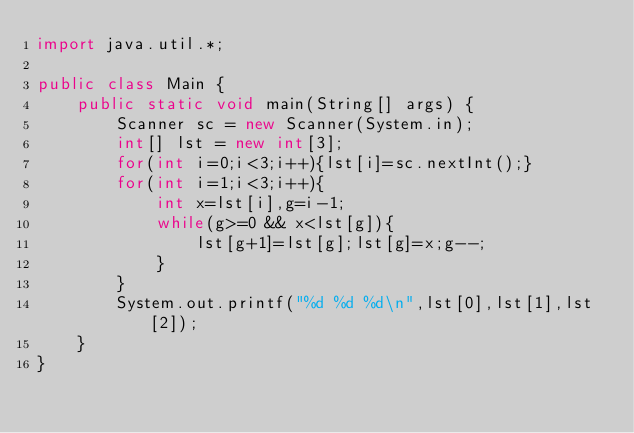Convert code to text. <code><loc_0><loc_0><loc_500><loc_500><_Java_>import java.util.*;

public class Main {
    public static void main(String[] args) {
        Scanner sc = new Scanner(System.in);
        int[] lst = new int[3];
        for(int i=0;i<3;i++){lst[i]=sc.nextInt();}
        for(int i=1;i<3;i++){
            int x=lst[i],g=i-1;
            while(g>=0 && x<lst[g]){
                lst[g+1]=lst[g];lst[g]=x;g--;
            }
        }
        System.out.printf("%d %d %d\n",lst[0],lst[1],lst[2]);
    }
}

</code> 